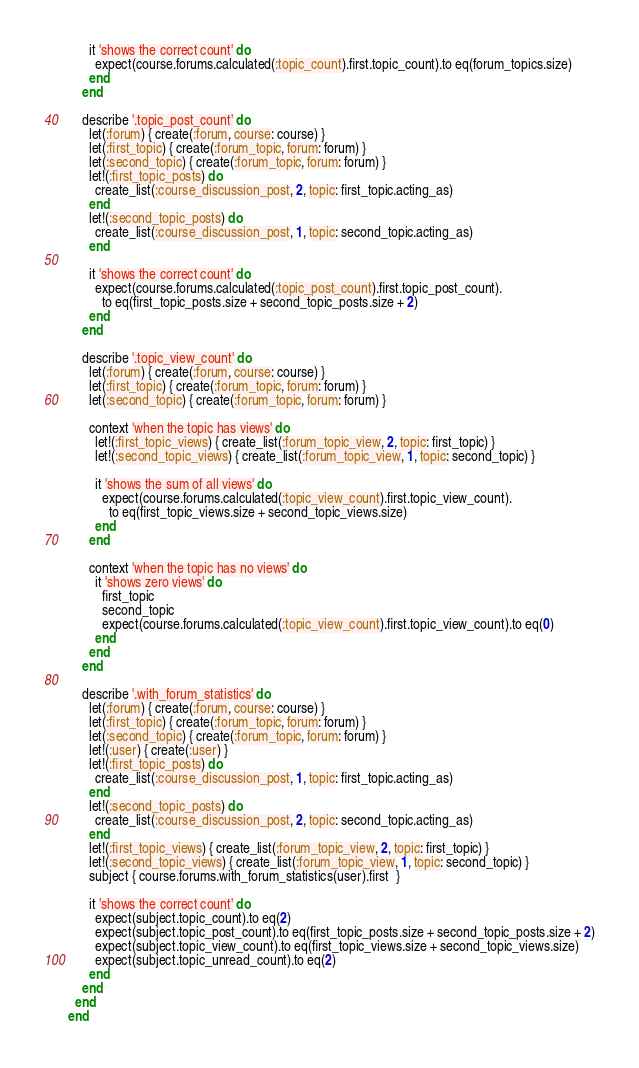Convert code to text. <code><loc_0><loc_0><loc_500><loc_500><_Ruby_>      it 'shows the correct count' do
        expect(course.forums.calculated(:topic_count).first.topic_count).to eq(forum_topics.size)
      end
    end

    describe '.topic_post_count' do
      let(:forum) { create(:forum, course: course) }
      let(:first_topic) { create(:forum_topic, forum: forum) }
      let(:second_topic) { create(:forum_topic, forum: forum) }
      let!(:first_topic_posts) do
        create_list(:course_discussion_post, 2, topic: first_topic.acting_as)
      end
      let!(:second_topic_posts) do
        create_list(:course_discussion_post, 1, topic: second_topic.acting_as)
      end

      it 'shows the correct count' do
        expect(course.forums.calculated(:topic_post_count).first.topic_post_count).
          to eq(first_topic_posts.size + second_topic_posts.size + 2)
      end
    end

    describe '.topic_view_count' do
      let(:forum) { create(:forum, course: course) }
      let(:first_topic) { create(:forum_topic, forum: forum) }
      let(:second_topic) { create(:forum_topic, forum: forum) }

      context 'when the topic has views' do
        let!(:first_topic_views) { create_list(:forum_topic_view, 2, topic: first_topic) }
        let!(:second_topic_views) { create_list(:forum_topic_view, 1, topic: second_topic) }

        it 'shows the sum of all views' do
          expect(course.forums.calculated(:topic_view_count).first.topic_view_count).
            to eq(first_topic_views.size + second_topic_views.size)
        end
      end

      context 'when the topic has no views' do
        it 'shows zero views' do
          first_topic
          second_topic
          expect(course.forums.calculated(:topic_view_count).first.topic_view_count).to eq(0)
        end
      end
    end

    describe '.with_forum_statistics' do
      let(:forum) { create(:forum, course: course) }
      let(:first_topic) { create(:forum_topic, forum: forum) }
      let(:second_topic) { create(:forum_topic, forum: forum) }
      let!(:user) { create(:user) }
      let!(:first_topic_posts) do
        create_list(:course_discussion_post, 1, topic: first_topic.acting_as)
      end
      let!(:second_topic_posts) do
        create_list(:course_discussion_post, 2, topic: second_topic.acting_as)
      end
      let!(:first_topic_views) { create_list(:forum_topic_view, 2, topic: first_topic) }
      let!(:second_topic_views) { create_list(:forum_topic_view, 1, topic: second_topic) }
      subject { course.forums.with_forum_statistics(user).first  }

      it 'shows the correct count' do
        expect(subject.topic_count).to eq(2)
        expect(subject.topic_post_count).to eq(first_topic_posts.size + second_topic_posts.size + 2)
        expect(subject.topic_view_count).to eq(first_topic_views.size + second_topic_views.size)
        expect(subject.topic_unread_count).to eq(2)
      end
    end
  end
end
</code> 